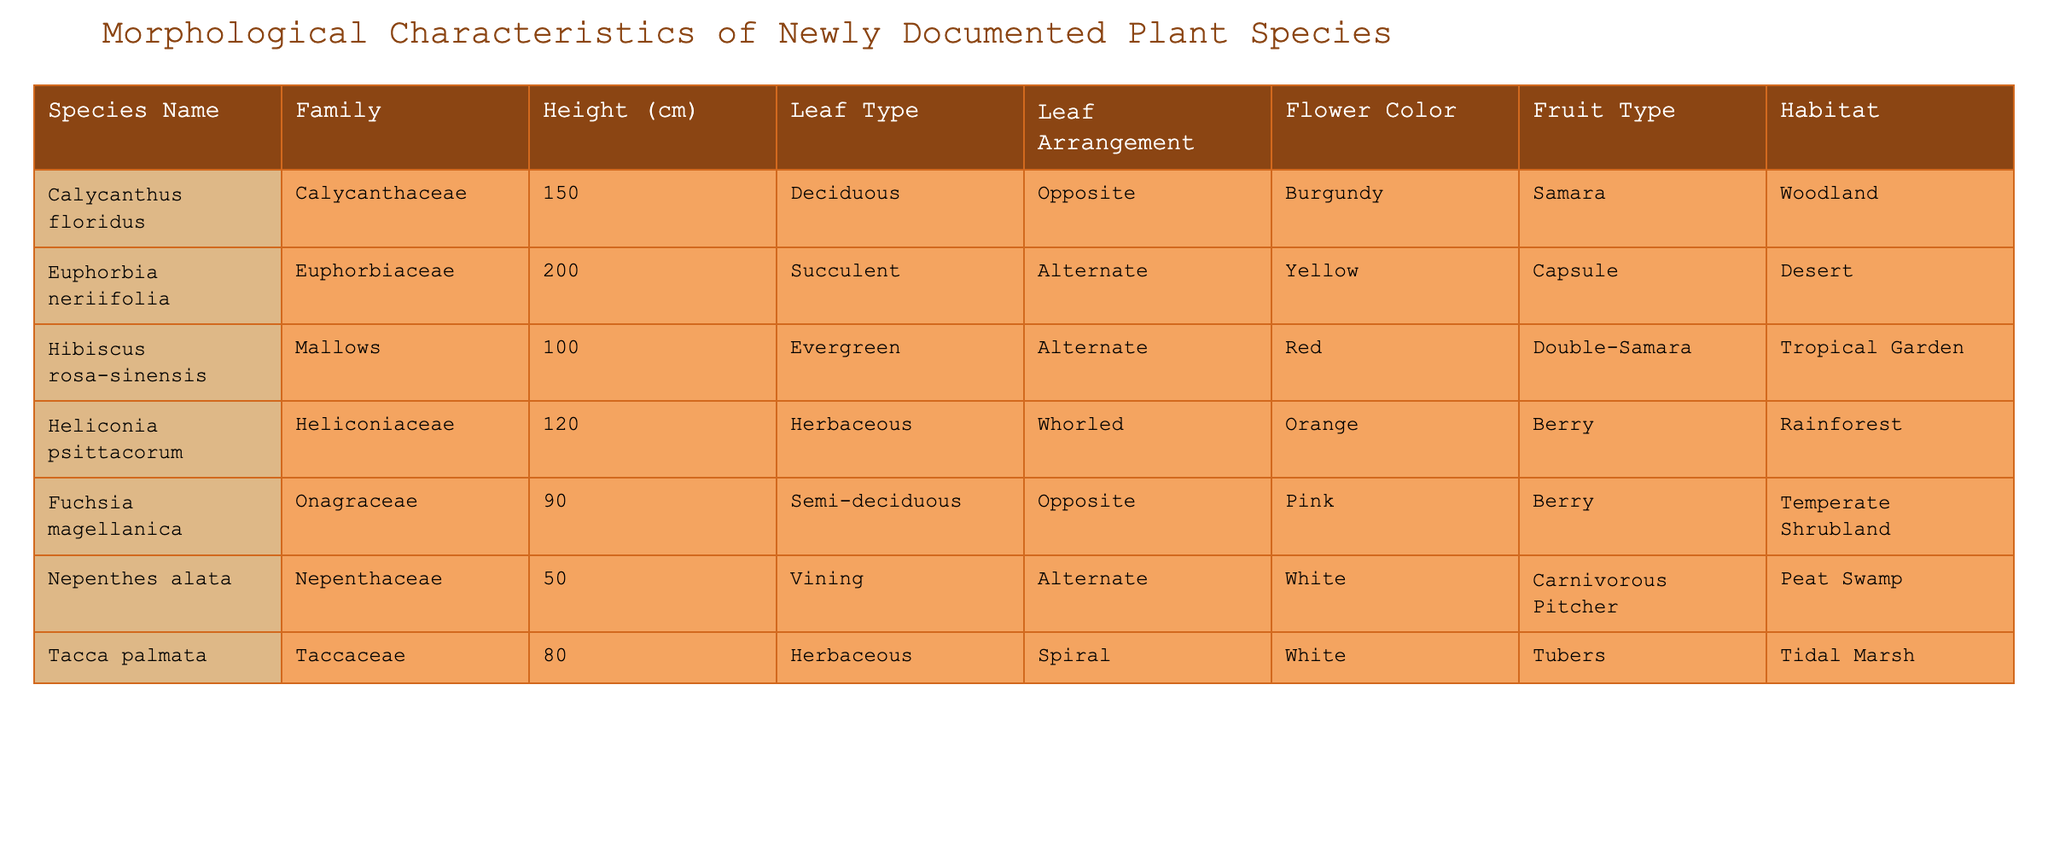What is the height of Hibiscus rosa-sinensis? The height of Hibiscus rosa-sinensis is listed directly in the table under the "Height (cm)" column. Its value is 100 cm.
Answer: 100 cm Which species belongs to the family Euphorbiaceae? The species listed under the family Euphorbiaceae is Euphorbia neriifolia, based on the table data provided.
Answer: Euphorbia neriifolia What is the fruit type of Calycanthus floridus? The fruit type for Calycanthus floridus is found in the "Fruit Type" column of the table, which states it is "Samara."
Answer: Samara Is the flower color of Heliconia psittacorum orange? The flower color for Heliconia psittacorum is stated as orange in the table, confirming the fact as true.
Answer: Yes What is the average height of the species in the table? To find the average height, we sum the heights of all species: 150 + 200 + 100 + 120 + 90 + 50 + 80 = 890 cm. There are 7 species, so the average height is 890 / 7 ≈ 127.14 cm.
Answer: 127.14 cm How many species have a leaf arrangement of "Alternate"? The species with "Alternate" leaf arrangement are Euphorbia neriifolia, Hibiscus rosa-sinensis, and Nepenthes alata. Counting these reveals a total of 3 species.
Answer: 3 Which habitat is shared by the most species in the table? Examining the "Habitat" column, Woodland, Desert, Tropical Garden, Rainforest, Temperate Shrubland, Peat Swamp, and Tidal Marsh each have only one corresponding species. Therefore, no habitat is shared by multiple species.
Answer: None What is the difference in height between the tallest and shortest species? The tallest species is Euphorbia neriifolia at 200 cm, and the shortest is Nepenthes alata at 50 cm. The difference in height is calculated as 200 - 50 = 150 cm.
Answer: 150 cm 